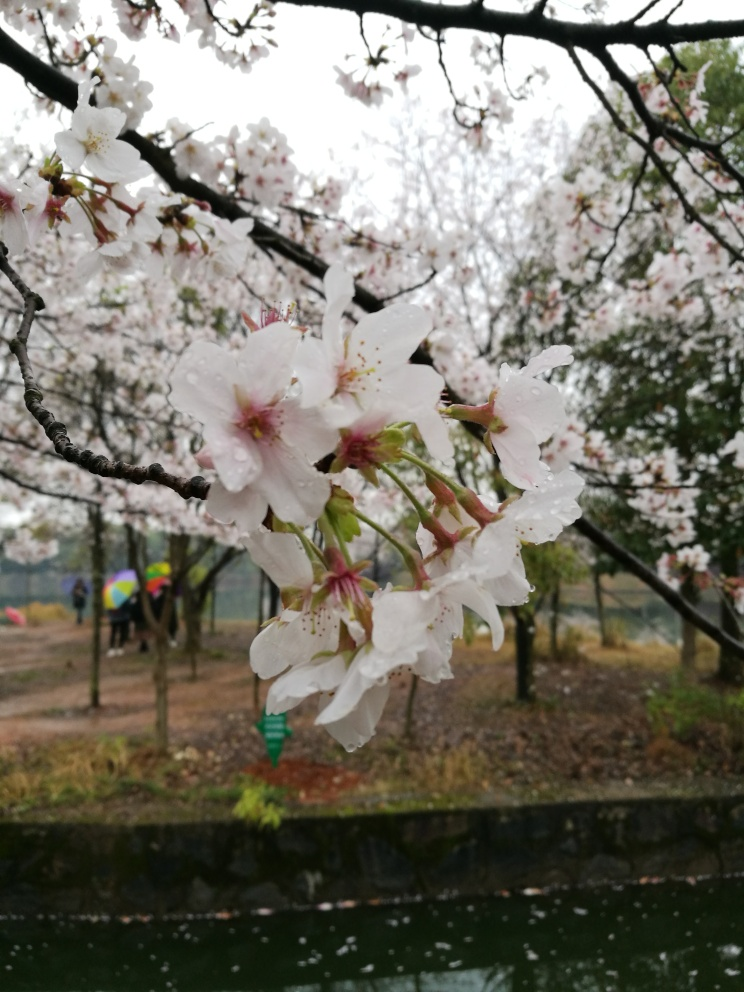What time of year does this image suggest? The presence of cherry blossoms in this image suggests that it was likely taken in early spring, which is the typical blooming season for these types of flowers. 